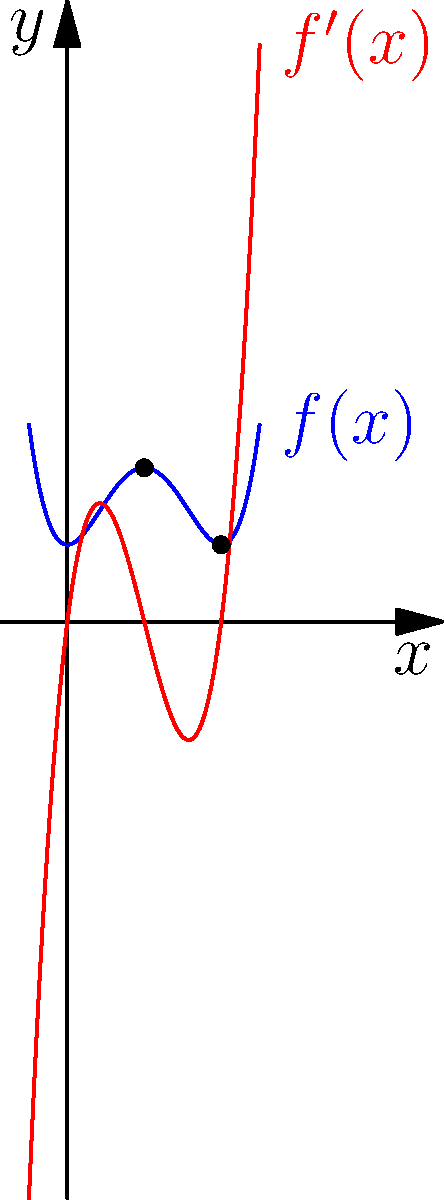Consider the quartic polynomial $f(x) = x^4 - 4x^3 + 4x^2 + 1$ and its derivative $f'(x) = 4x^3 - 12x^2 + 8x$. The graph shows $f(x)$ in blue and $f'(x)$ in red. What can you conclude about the behavior of $f(x)$ near its local extrema at $x=1$ and $x=2$? To analyze the behavior of $f(x)$ near its local extrema, we'll follow these steps:

1) Identify the local extrema:
   The local extrema occur where $f'(x) = 0$. From the graph, we can see that $f'(x)$ crosses the x-axis at $x=1$ and $x=2$.

2) Determine the nature of the extrema:
   - At $x=1$: $f'(x)$ changes from negative to positive, indicating a local minimum.
   - At $x=2$: $f'(x)$ changes from positive to negative, indicating a local maximum.

3) Analyze the second derivative:
   $f''(x) = 12x^2 - 24x + 8$
   - At $x=1$: $f''(1) = 12 - 24 + 8 = -4 < 0$, confirming a local minimum.
   - At $x=2$: $f''(2) = 48 - 48 + 8 = 8 > 0$, confirming a local maximum.

4) Observe the graph:
   - Near $x=1$, the function curves upward (convex).
   - Near $x=2$, the function curves downward (concave).

5) Analyze the rate of change:
   - As $x$ approaches 1 from either side, $f'(x)$ approaches 0 linearly.
   - As $x$ approaches 2 from either side, $f'(x)$ also approaches 0 linearly.

This linear approach of $f'(x)$ to 0 near both extrema indicates that $f(x)$ behaves approximately quadratically near these points, but with opposite curvatures.
Answer: $f(x)$ behaves approximately quadratically near both extrema, with upward curvature at the local minimum ($x=1$) and downward curvature at the local maximum ($x=2$). 